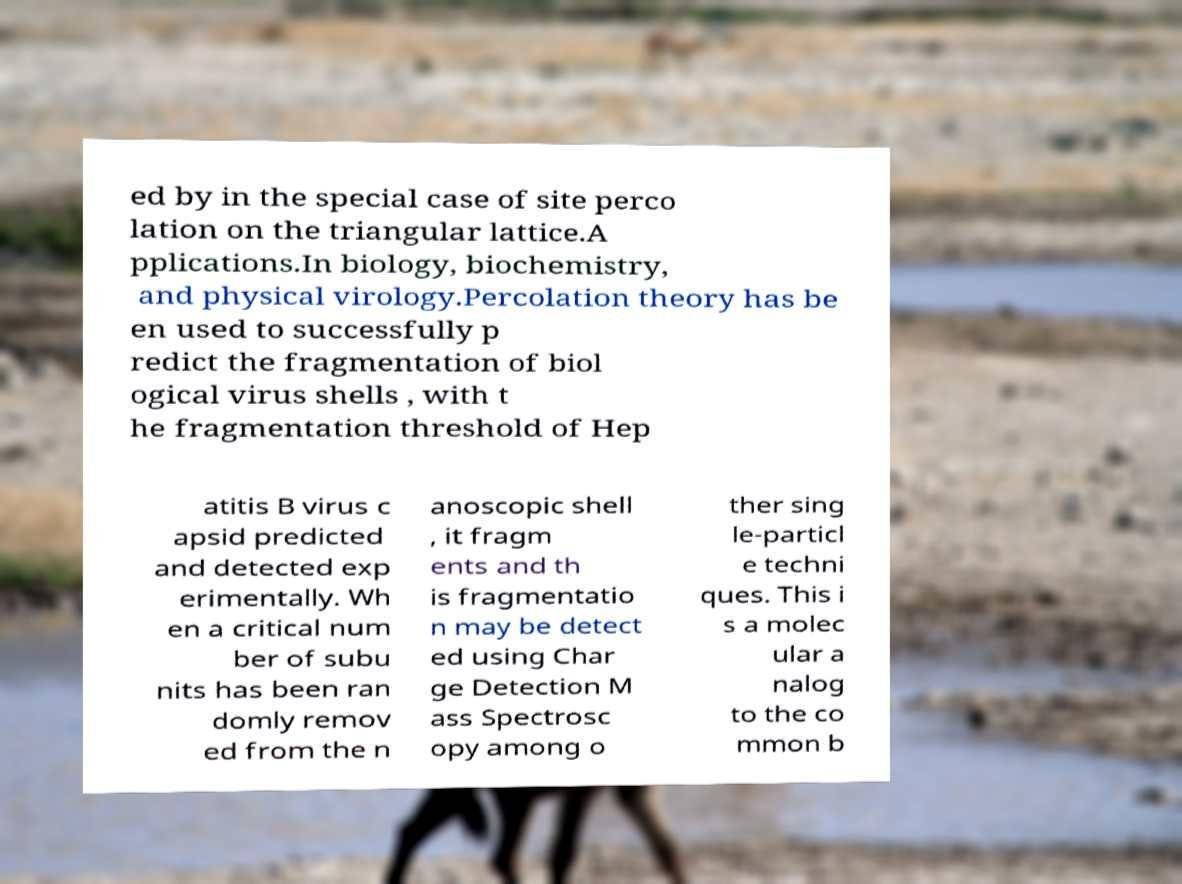Could you extract and type out the text from this image? ed by in the special case of site perco lation on the triangular lattice.A pplications.In biology, biochemistry, and physical virology.Percolation theory has be en used to successfully p redict the fragmentation of biol ogical virus shells , with t he fragmentation threshold of Hep atitis B virus c apsid predicted and detected exp erimentally. Wh en a critical num ber of subu nits has been ran domly remov ed from the n anoscopic shell , it fragm ents and th is fragmentatio n may be detect ed using Char ge Detection M ass Spectrosc opy among o ther sing le-particl e techni ques. This i s a molec ular a nalog to the co mmon b 